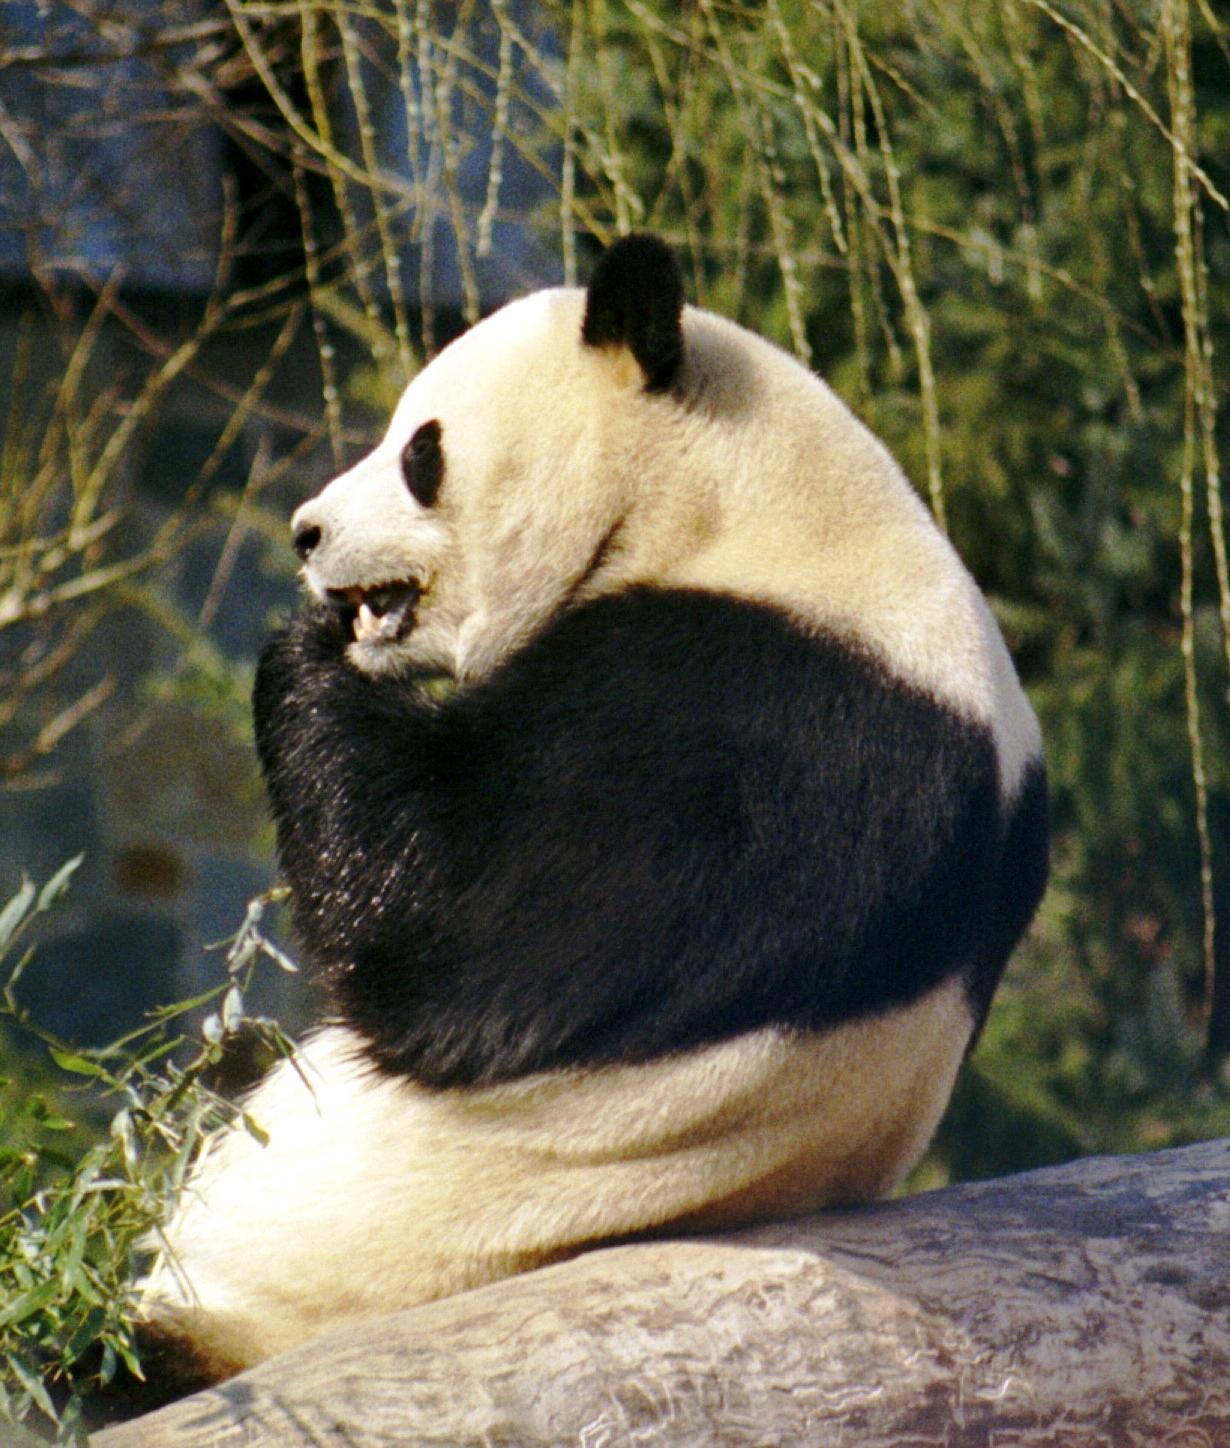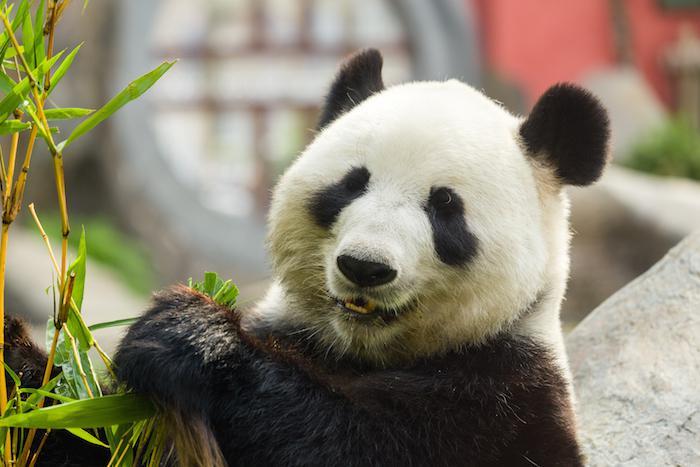The first image is the image on the left, the second image is the image on the right. Given the left and right images, does the statement "The panda on the left image is on a tree branch." hold true? Answer yes or no. No. 